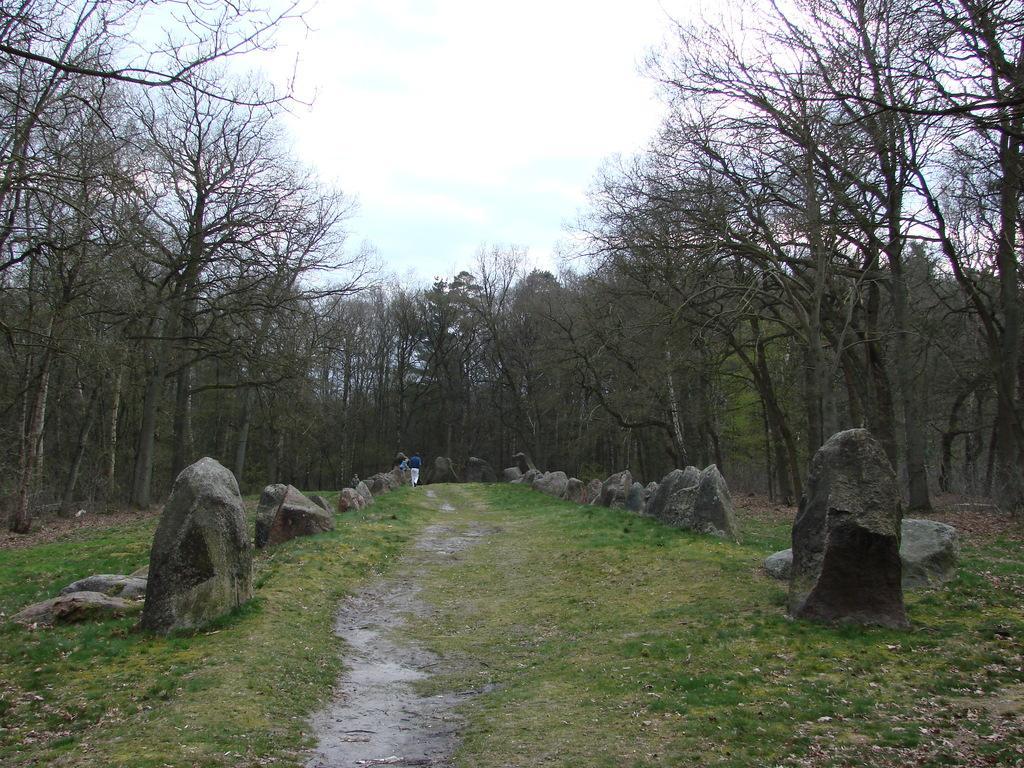In one or two sentences, can you explain what this image depicts? In this image, we can see people and there are rocks on the ground. In the background, there are trees. At the top, there is sky. 